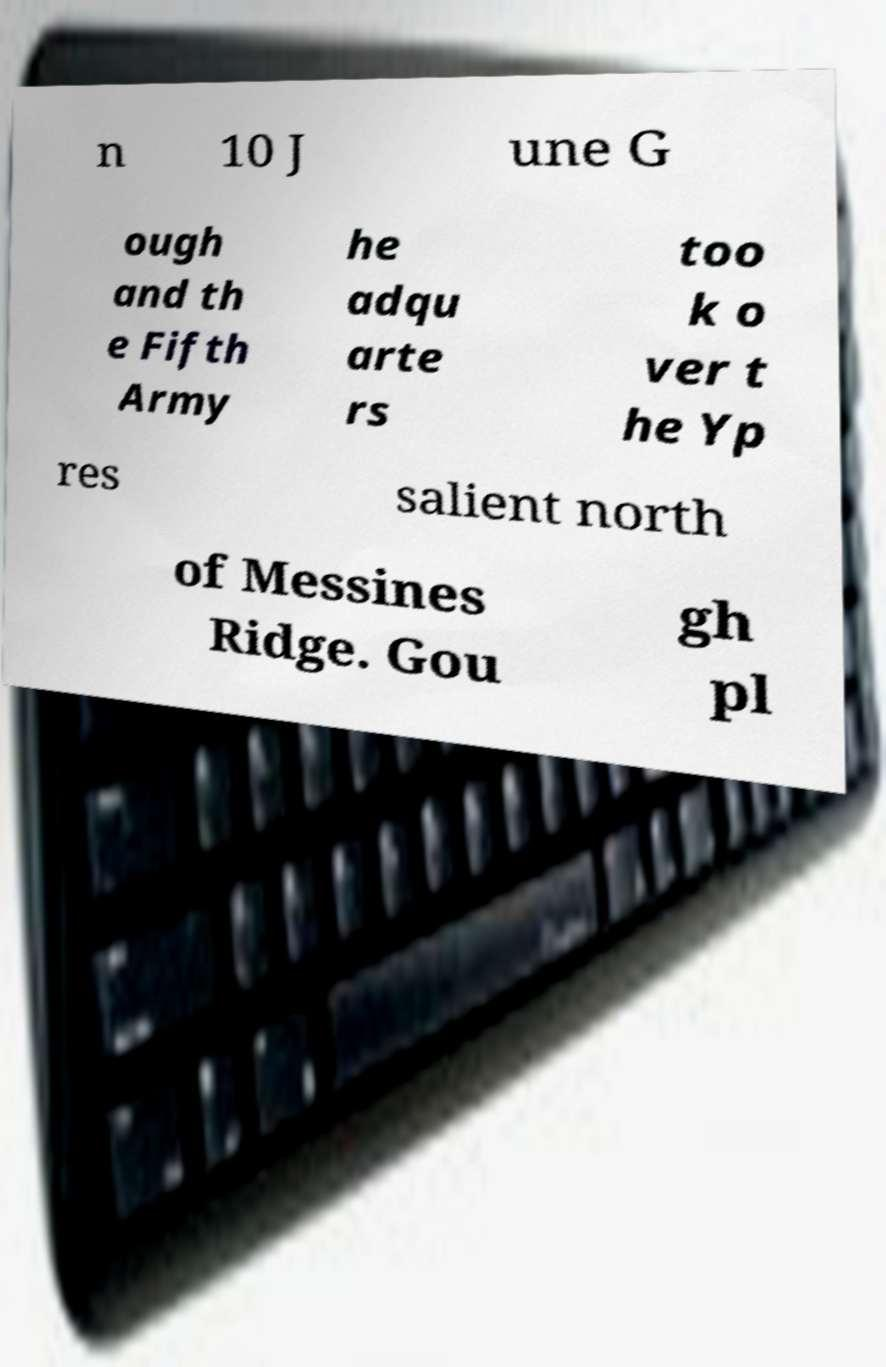Please read and relay the text visible in this image. What does it say? n 10 J une G ough and th e Fifth Army he adqu arte rs too k o ver t he Yp res salient north of Messines Ridge. Gou gh pl 